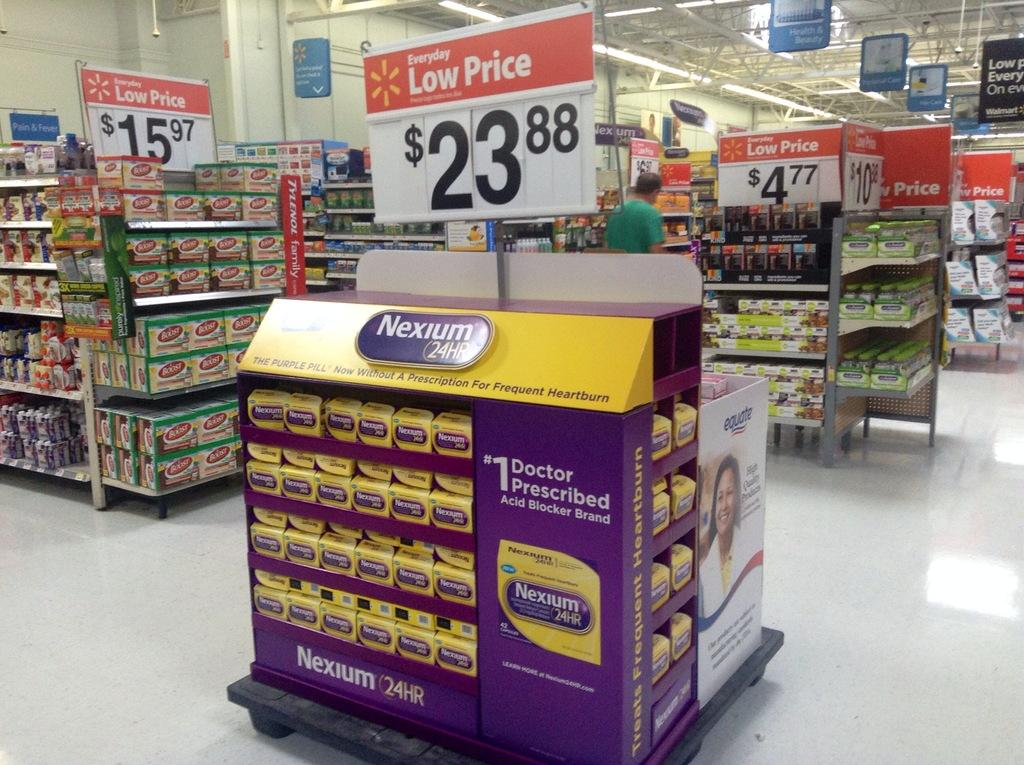<image>
Offer a succinct explanation of the picture presented. Section in a supermarket selling Nexium for 23.88. 